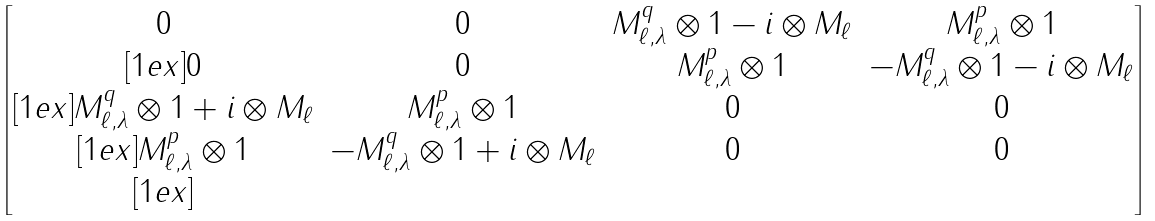<formula> <loc_0><loc_0><loc_500><loc_500>\begin{bmatrix} 0 & 0 & M _ { \ell , \lambda } ^ { q } \otimes 1 - i \otimes M _ { \ell } & M _ { \ell , \lambda } ^ { p } \otimes 1 \\ [ 1 e x ] 0 & 0 & M _ { \ell , \lambda } ^ { p } \otimes 1 & - M _ { \ell , \lambda } ^ { q } \otimes 1 - i \otimes M _ { \ell } \\ [ 1 e x ] M _ { \ell , \lambda } ^ { q } \otimes 1 + i \otimes M _ { \ell } & M _ { \ell , \lambda } ^ { p } \otimes 1 & 0 & 0 \\ [ 1 e x ] M _ { \ell , \lambda } ^ { p } \otimes 1 & - M _ { \ell , \lambda } ^ { q } \otimes 1 + i \otimes M _ { \ell } & 0 & 0 \\ [ 1 e x ] \end{bmatrix}</formula> 